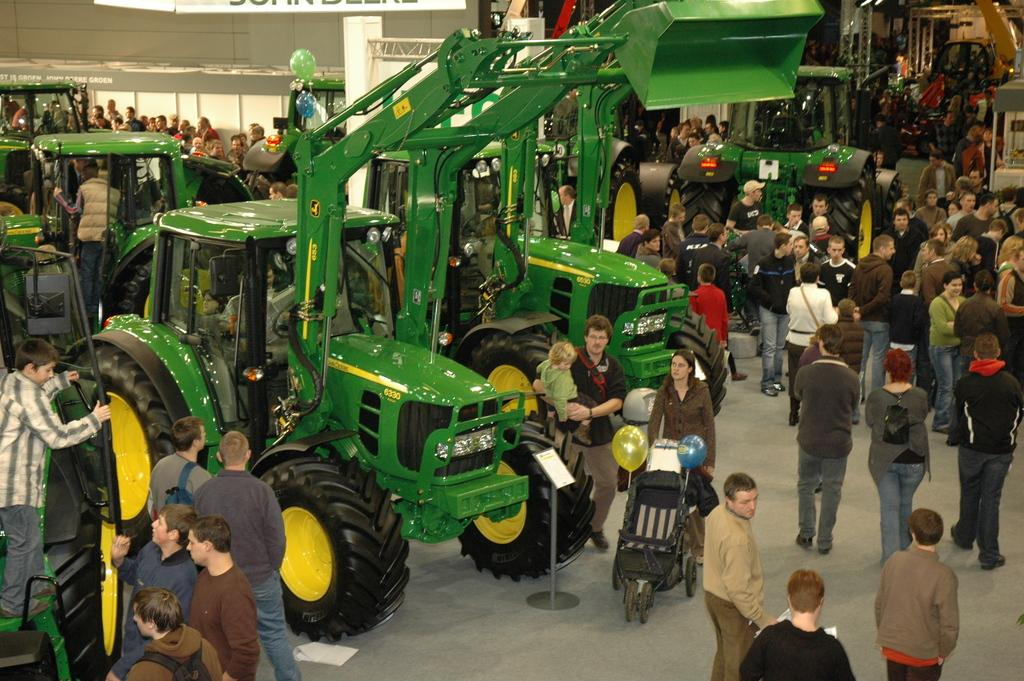What types of objects can be seen in the image that are used for transportation? There are vehicles in the image. What is being used to transport a child in the image? There is a stroller in the image for transporting a child. What decorative items can be seen in the image? Balloons are present in the image. What structure is visible in the image that might be used for displaying items? There is a stand in the image that could be used for displaying items. How many people are standing in the image? There is a group of people standing on the floor in the image. Can you tell me how many people are swimming in the image? There is no swimming activity depicted in the image; it features vehicles, a stroller, balloons, a stand, and a group of people standing on the floor. What type of room is shown in the image? The image does not depict a room; it is an outdoor scene with vehicles, a stroller, balloons, a stand, and a group of people standing on the floor. 